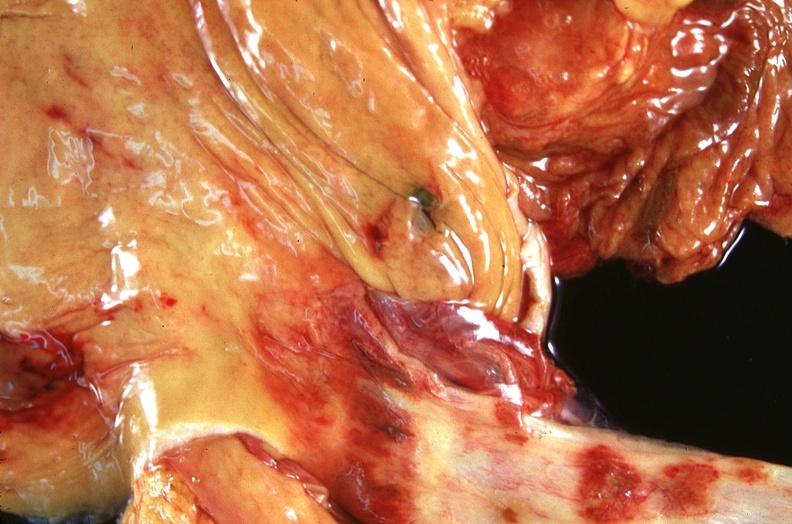does stillborn cord around neck show stomach and esophagus, ulcers?
Answer the question using a single word or phrase. No 